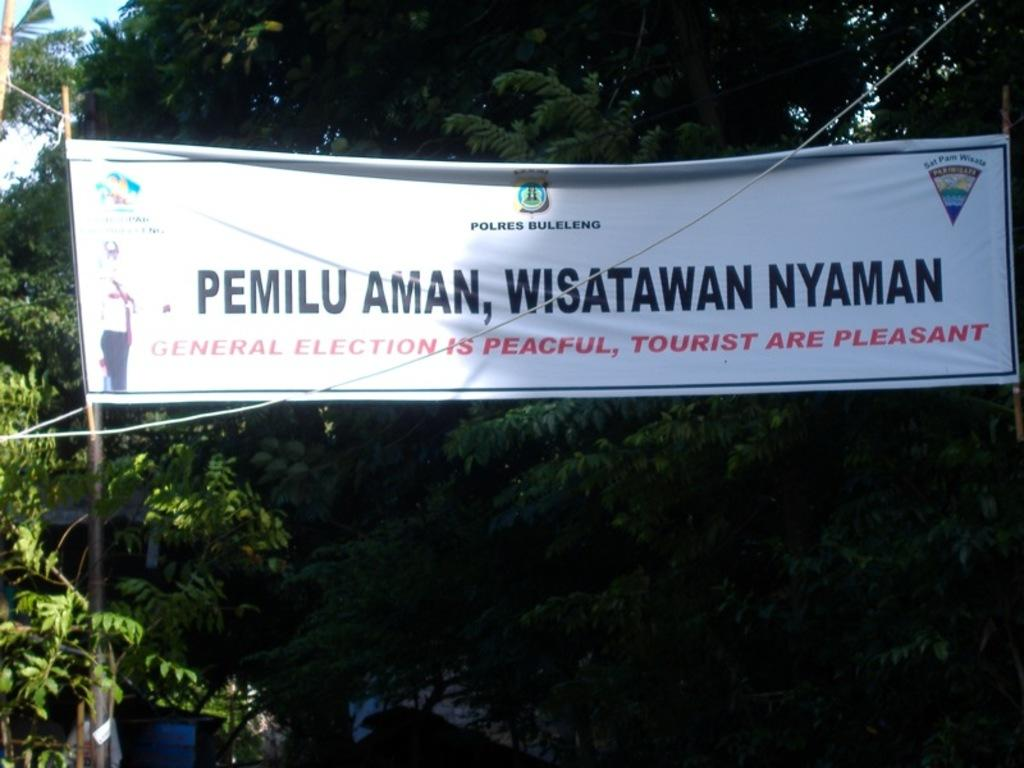What is the main object in the image? There is a banner in the image. What can be seen behind the banner? There are trees behind the banner. What is written or displayed on the banner? There is text or matter written on the banner. How many buttons are attached to the banner in the image? There are no buttons present on the banner in the image. 